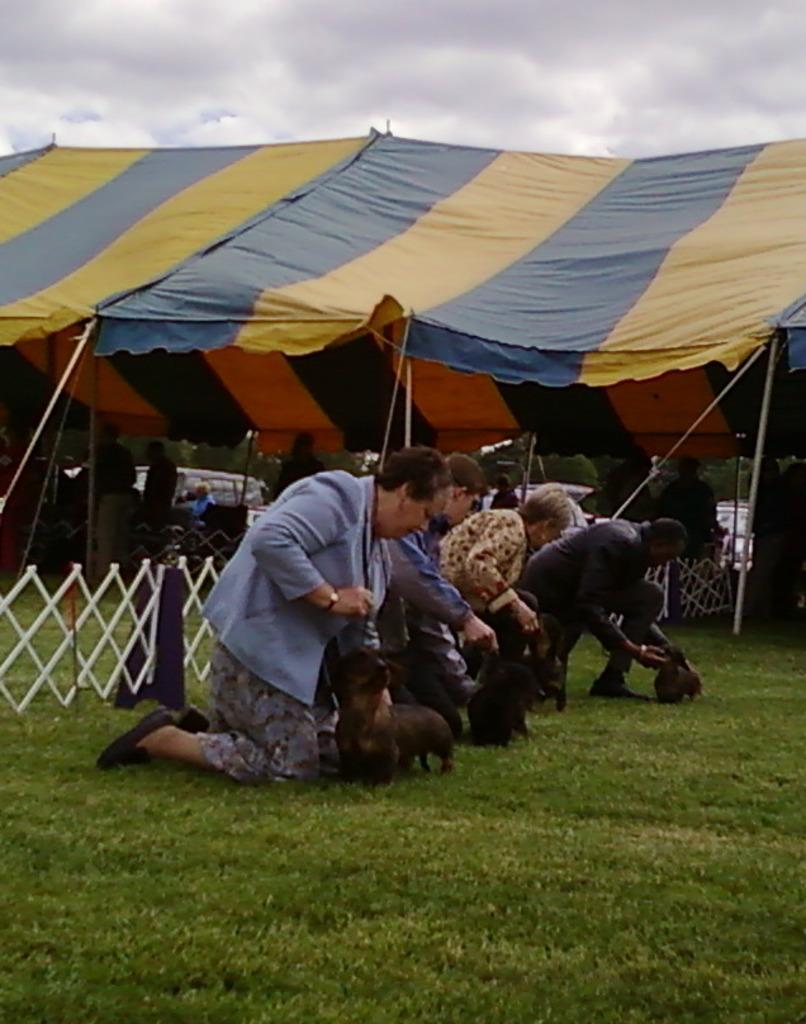Can you describe this image briefly? In this image there is group of four person who are in a squat position and they are holding a small dogs. On the bottom there is a green grass. On the left there is a white color fencing. On the top we can see a sky with full of clouds. On the center there is a tent, under the tent we can see some peoples are standing. 